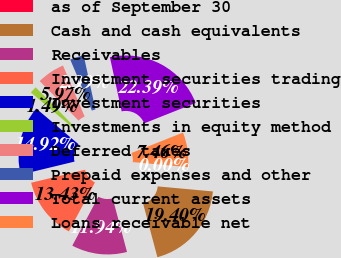<chart> <loc_0><loc_0><loc_500><loc_500><pie_chart><fcel>as of September 30<fcel>Cash and cash equivalents<fcel>Receivables<fcel>Investment securities trading<fcel>Investment securities<fcel>Investments in equity method<fcel>Deferred taxes<fcel>Prepaid expenses and other<fcel>Total current assets<fcel>Loans receivable net<nl><fcel>0.0%<fcel>19.4%<fcel>11.94%<fcel>13.43%<fcel>14.92%<fcel>1.49%<fcel>5.97%<fcel>2.99%<fcel>22.39%<fcel>7.46%<nl></chart> 